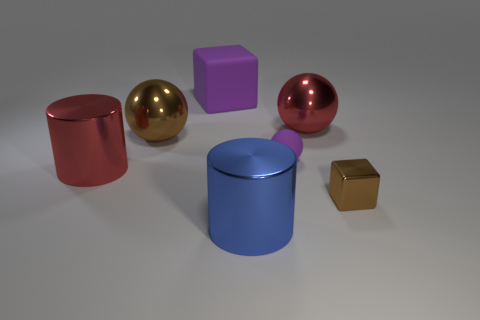Does the tiny sphere have the same material as the purple thing behind the small rubber ball?
Offer a terse response. Yes. What color is the cube in front of the red object behind the small ball that is in front of the red metal ball?
Make the answer very short. Brown. What shape is the blue metallic thing that is the same size as the purple block?
Your answer should be very brief. Cylinder. Does the cylinder that is on the left side of the large purple rubber object have the same size as the purple matte thing right of the big blue metal cylinder?
Give a very brief answer. No. There is a brown ball that is to the left of the big blue cylinder; what size is it?
Make the answer very short. Large. What material is the big block that is the same color as the small rubber sphere?
Offer a terse response. Rubber. There is a object that is the same size as the matte ball; what is its color?
Give a very brief answer. Brown. Do the red cylinder and the purple rubber sphere have the same size?
Your answer should be compact. No. What is the size of the metallic object that is in front of the small matte sphere and right of the matte sphere?
Keep it short and to the point. Small. How many matte things are either blue things or brown things?
Your answer should be very brief. 0. 